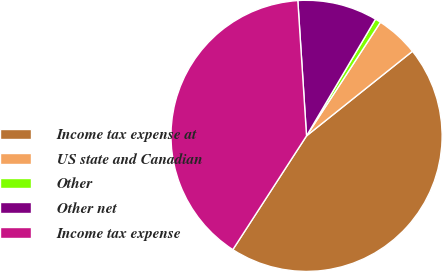Convert chart. <chart><loc_0><loc_0><loc_500><loc_500><pie_chart><fcel>Income tax expense at<fcel>US state and Canadian<fcel>Other<fcel>Other net<fcel>Income tax expense<nl><fcel>44.88%<fcel>5.1%<fcel>0.68%<fcel>9.52%<fcel>39.83%<nl></chart> 